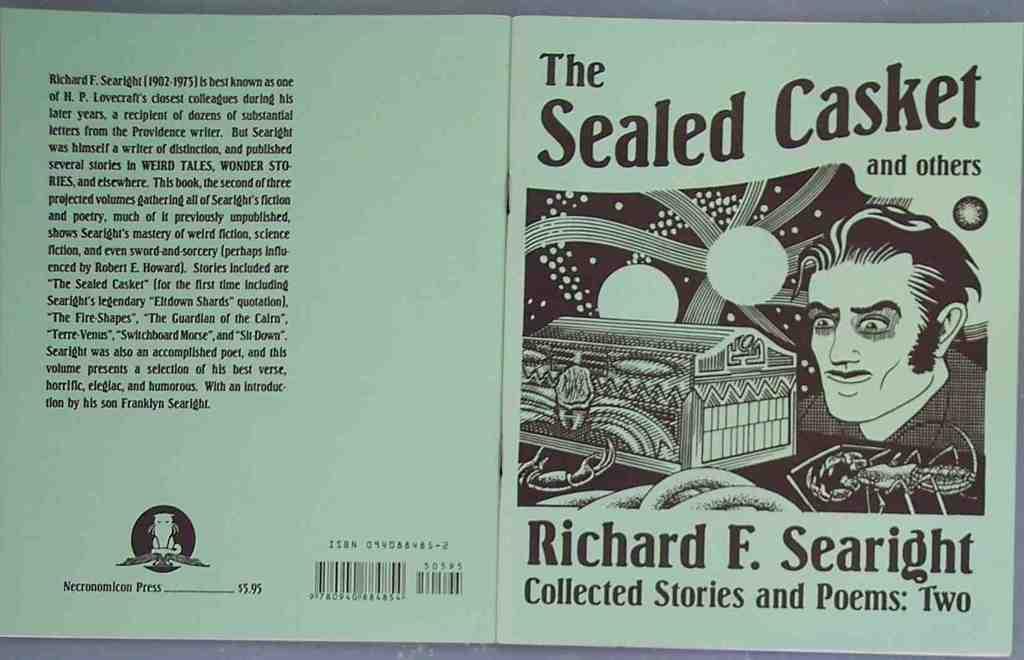Who is the author?
Provide a succinct answer. Richard f. searight. 